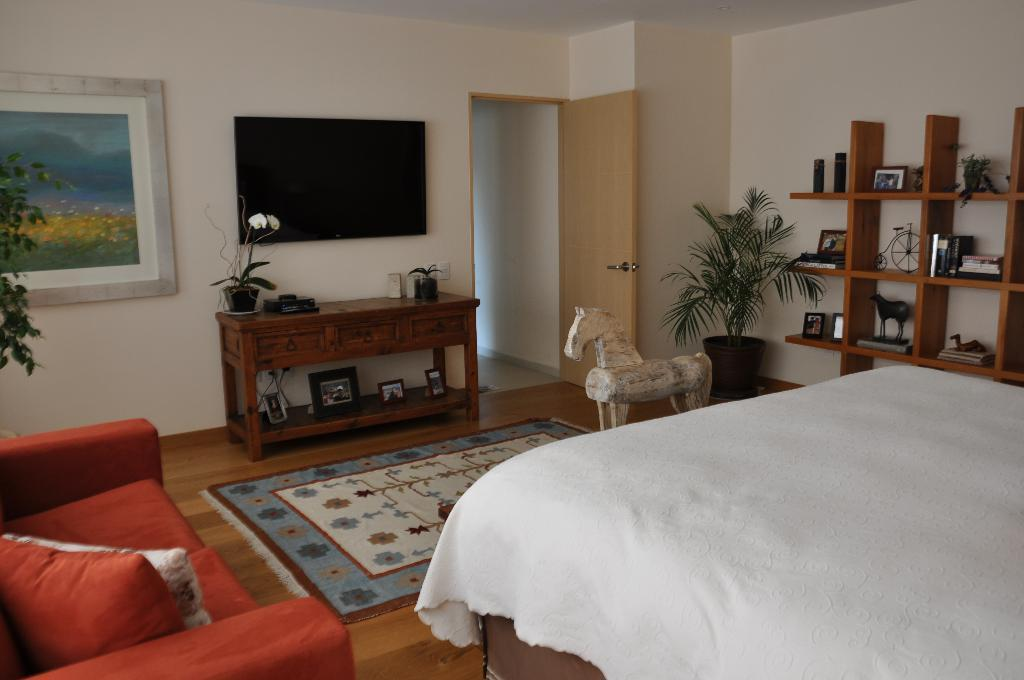What type of furniture is present in the image? There is a bed, a couch, and a table in the image. What is mounted on the wall in the image? There is a TV on a wall in the image. What type of storage unit is present in the image? There is a shelf in the image. What is the entrance to the room in the image? There is a door in the image. What is on the floor in the image? There is a mat on the floor in the image. What type of wheel can be seen on the bed in the image? There is no wheel present on the bed in the image. How does the club expand in the image? There is no club present in the image, so it cannot expand. 